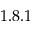Convert formula to latex. <formula><loc_0><loc_0><loc_500><loc_500>1 . 8 . 1</formula> 